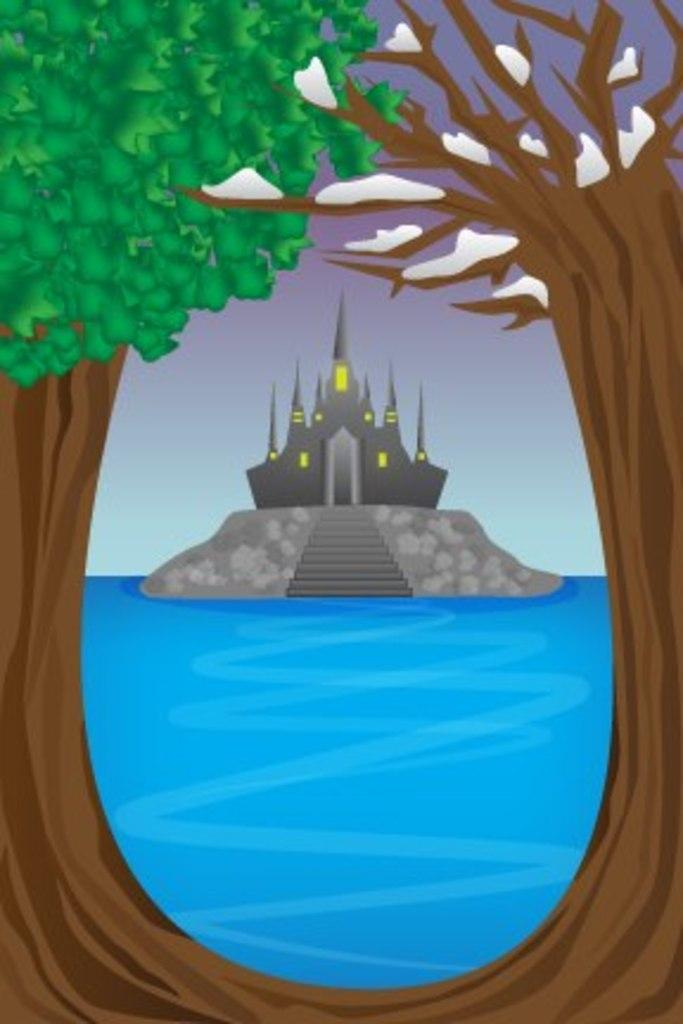What type of artwork is depicted in the image? The image is a drawing. What natural elements are present in the drawing? There are trees and water in the drawing. Can you describe the placement of the rock in the drawing? There is a rock in the water, and a building is on top of the rock. What architectural feature is present on the rock? There are steps on the rock. What can be seen in the background of the drawing? There is sky visible in the background of the drawing. How many sheep are grazing on the steps in the drawing? There are no sheep present in the drawing; it features a rock with steps and a building. What word is used to describe the water in the drawing? The provided facts do not specify a word to describe the water in the drawing, but it is depicted as a body of water. 